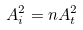<formula> <loc_0><loc_0><loc_500><loc_500>A _ { i } ^ { 2 } = n A _ { t } ^ { 2 }</formula> 